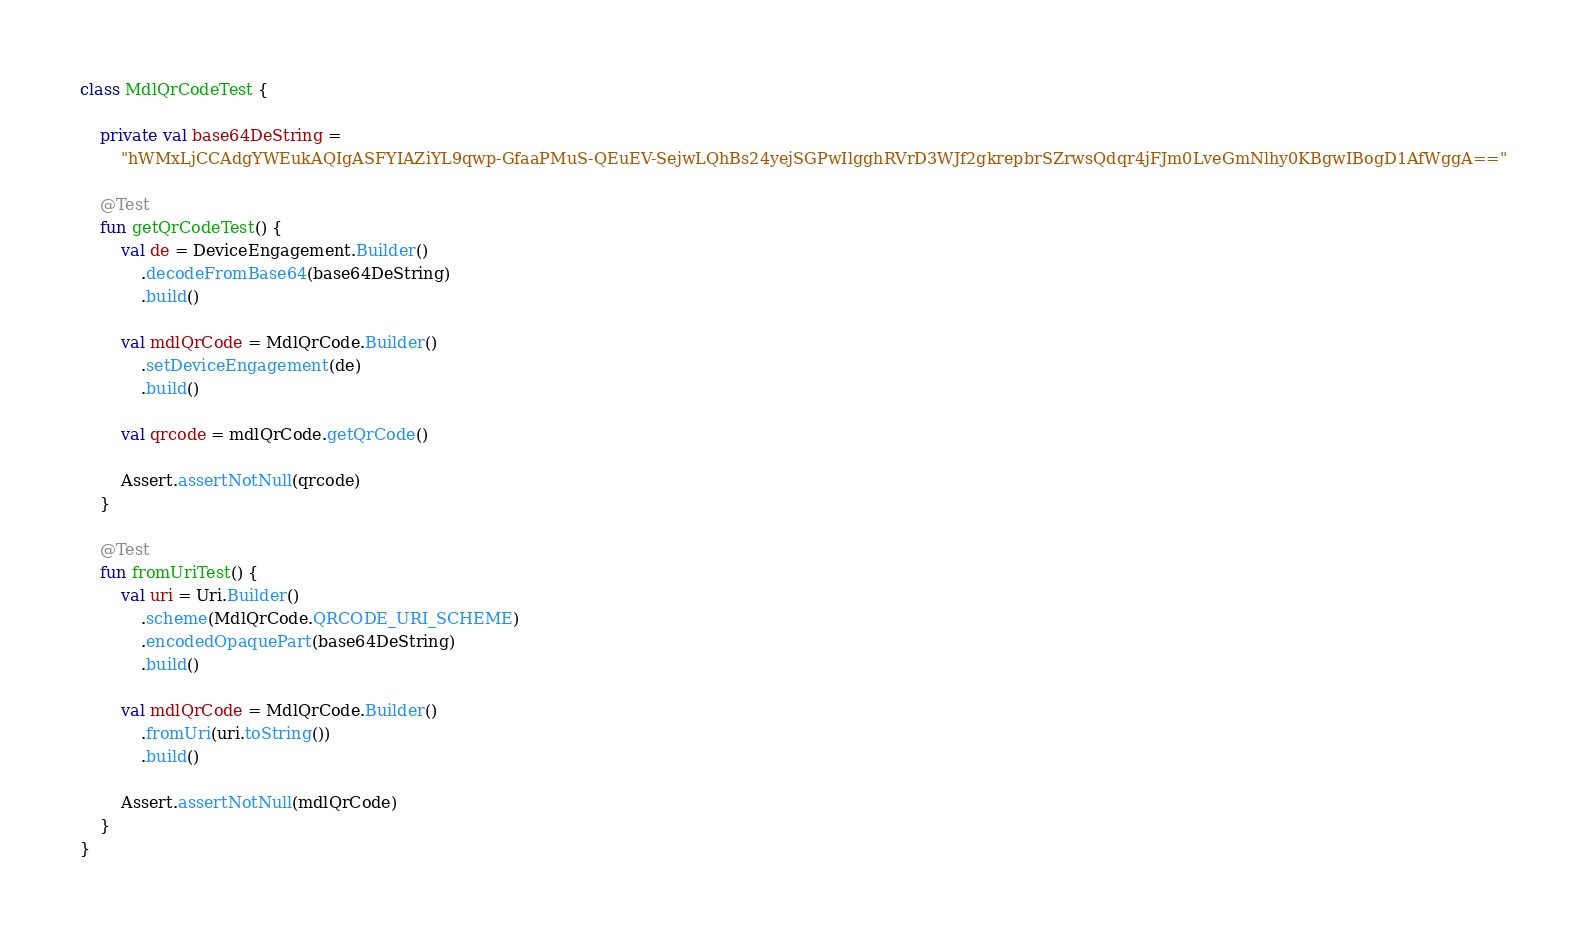Convert code to text. <code><loc_0><loc_0><loc_500><loc_500><_Kotlin_>class MdlQrCodeTest {

    private val base64DeString =
        "hWMxLjCCAdgYWEukAQIgASFYIAZiYL9qwp-GfaaPMuS-QEuEV-SejwLQhBs24yejSGPwIlgghRVrD3WJf2gkrepbrSZrwsQdqr4jFJm0LveGmNlhy0KBgwIBogD1AfWggA=="

    @Test
    fun getQrCodeTest() {
        val de = DeviceEngagement.Builder()
            .decodeFromBase64(base64DeString)
            .build()

        val mdlQrCode = MdlQrCode.Builder()
            .setDeviceEngagement(de)
            .build()

        val qrcode = mdlQrCode.getQrCode()

        Assert.assertNotNull(qrcode)
    }

    @Test
    fun fromUriTest() {
        val uri = Uri.Builder()
            .scheme(MdlQrCode.QRCODE_URI_SCHEME)
            .encodedOpaquePart(base64DeString)
            .build()

        val mdlQrCode = MdlQrCode.Builder()
            .fromUri(uri.toString())
            .build()

        Assert.assertNotNull(mdlQrCode)
    }
}</code> 